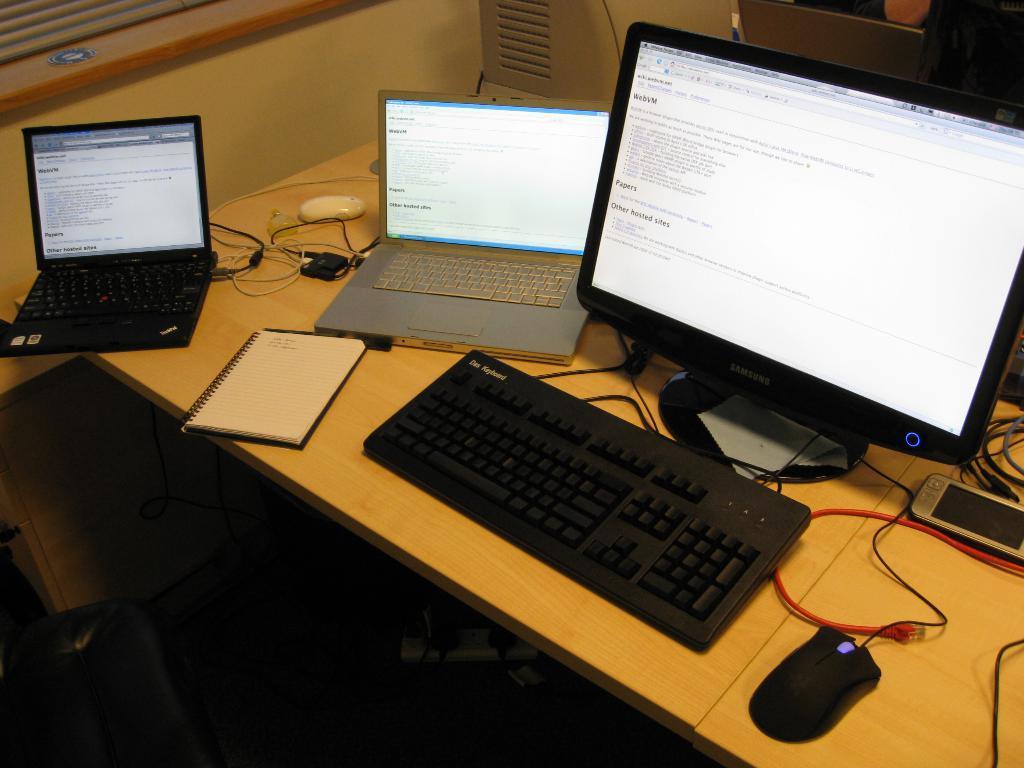Can you describe this image briefly? In the image there is a table. On the table there is a monitor, keyboard, laptops, a notepad, mouses, cable wires, a cloth and a mobile phone. Below the table there is a extension board. At the below left corner of the image there is a chair. 